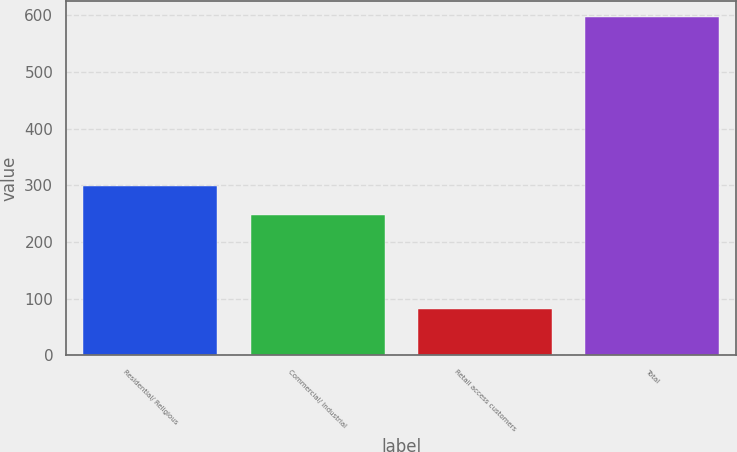Convert chart. <chart><loc_0><loc_0><loc_500><loc_500><bar_chart><fcel>Residential/ Religious<fcel>Commercial/ Industrial<fcel>Retail access customers<fcel>Total<nl><fcel>299.5<fcel>248<fcel>81<fcel>596<nl></chart> 